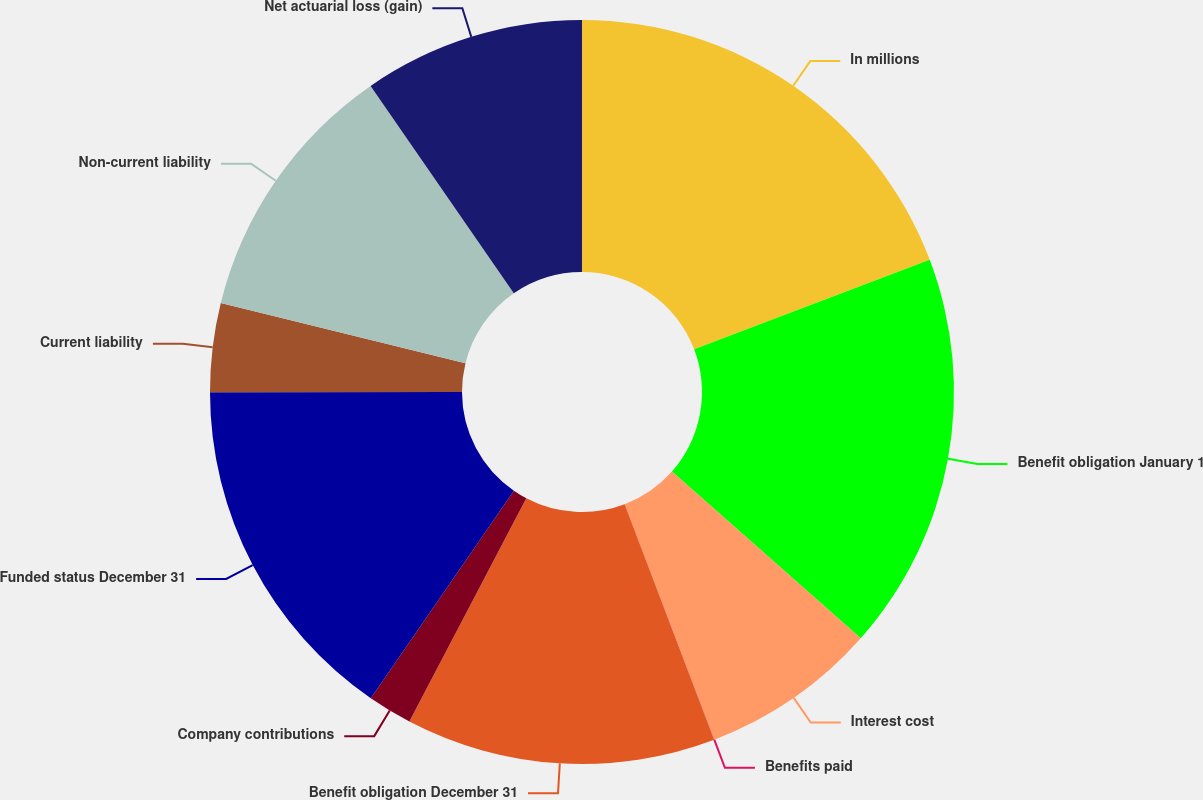Convert chart. <chart><loc_0><loc_0><loc_500><loc_500><pie_chart><fcel>In millions<fcel>Benefit obligation January 1<fcel>Interest cost<fcel>Benefits paid<fcel>Benefit obligation December 31<fcel>Company contributions<fcel>Funded status December 31<fcel>Current liability<fcel>Non-current liability<fcel>Net actuarial loss (gain)<nl><fcel>19.22%<fcel>17.3%<fcel>7.69%<fcel>0.01%<fcel>13.46%<fcel>1.93%<fcel>15.38%<fcel>3.85%<fcel>11.54%<fcel>9.62%<nl></chart> 